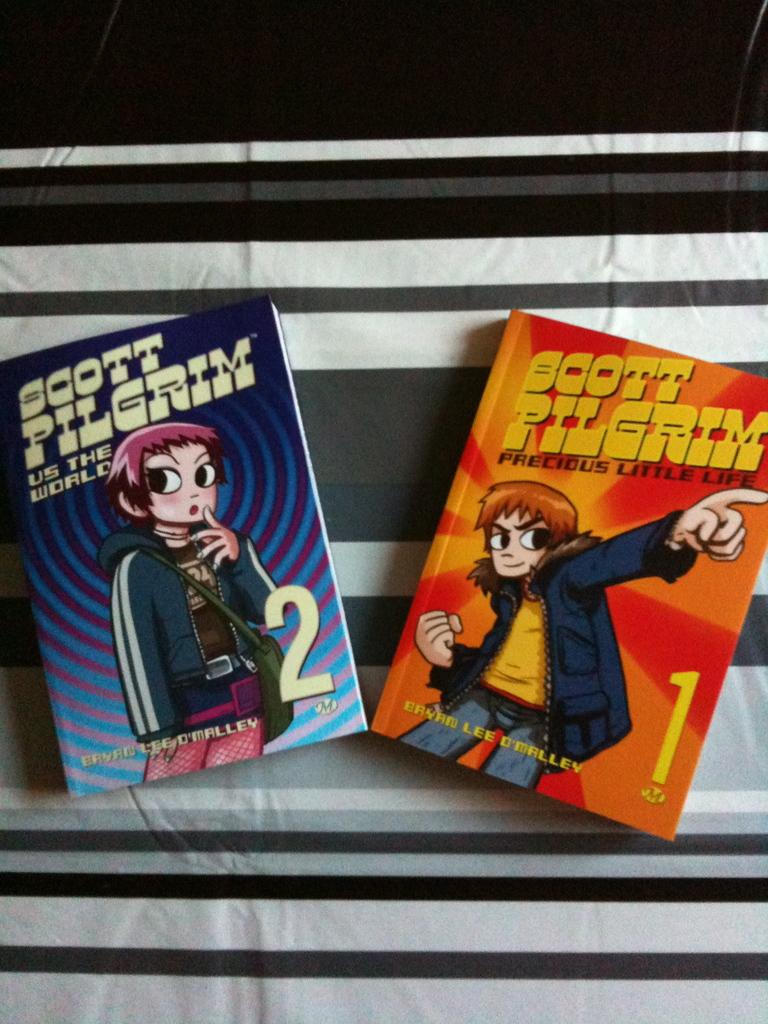<image>
Write a terse but informative summary of the picture. Books that have the title Scott Pilgrim on it. 